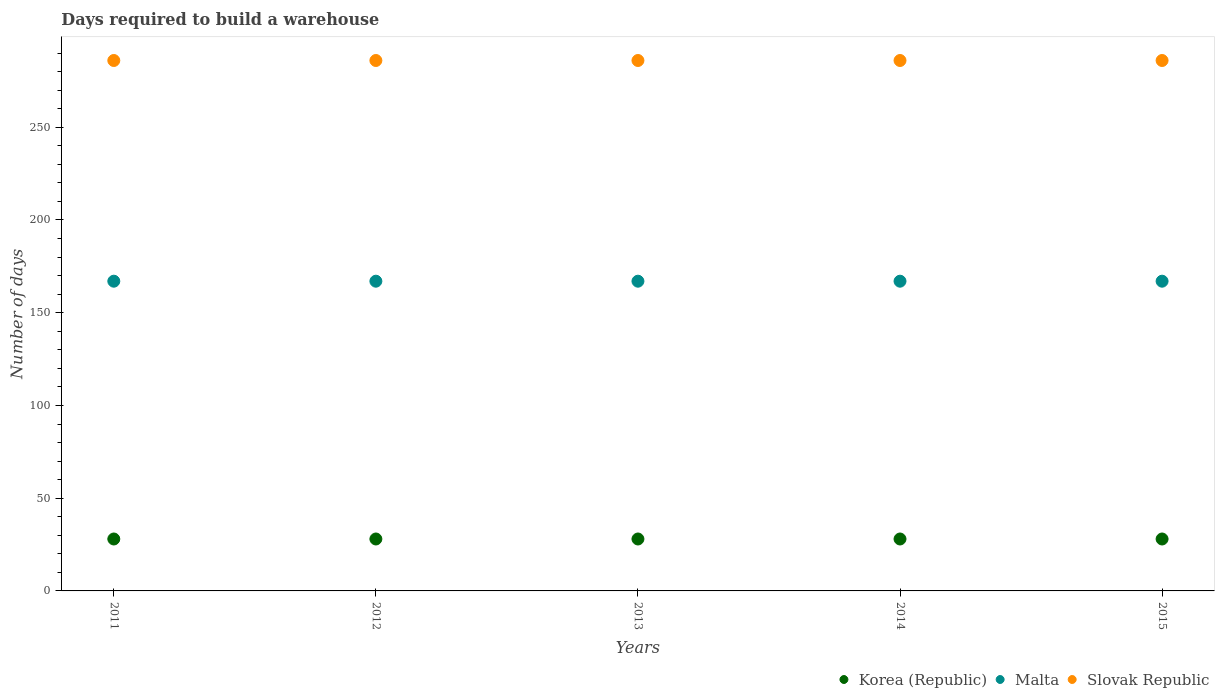Is the number of dotlines equal to the number of legend labels?
Ensure brevity in your answer.  Yes. What is the days required to build a warehouse in in Slovak Republic in 2012?
Your response must be concise. 286. Across all years, what is the maximum days required to build a warehouse in in Korea (Republic)?
Your response must be concise. 28. Across all years, what is the minimum days required to build a warehouse in in Korea (Republic)?
Give a very brief answer. 28. In which year was the days required to build a warehouse in in Korea (Republic) maximum?
Provide a succinct answer. 2011. In which year was the days required to build a warehouse in in Slovak Republic minimum?
Your answer should be very brief. 2011. What is the total days required to build a warehouse in in Malta in the graph?
Make the answer very short. 835. What is the difference between the days required to build a warehouse in in Korea (Republic) in 2011 and the days required to build a warehouse in in Slovak Republic in 2015?
Your answer should be compact. -258. What is the average days required to build a warehouse in in Malta per year?
Keep it short and to the point. 167. In the year 2012, what is the difference between the days required to build a warehouse in in Malta and days required to build a warehouse in in Korea (Republic)?
Make the answer very short. 139. What is the difference between the highest and the lowest days required to build a warehouse in in Slovak Republic?
Your answer should be compact. 0. Is it the case that in every year, the sum of the days required to build a warehouse in in Korea (Republic) and days required to build a warehouse in in Malta  is greater than the days required to build a warehouse in in Slovak Republic?
Offer a very short reply. No. Is the days required to build a warehouse in in Korea (Republic) strictly less than the days required to build a warehouse in in Malta over the years?
Ensure brevity in your answer.  Yes. How many years are there in the graph?
Provide a short and direct response. 5. What is the difference between two consecutive major ticks on the Y-axis?
Provide a succinct answer. 50. Does the graph contain any zero values?
Your response must be concise. No. Where does the legend appear in the graph?
Ensure brevity in your answer.  Bottom right. What is the title of the graph?
Give a very brief answer. Days required to build a warehouse. Does "Moldova" appear as one of the legend labels in the graph?
Your answer should be compact. No. What is the label or title of the Y-axis?
Provide a short and direct response. Number of days. What is the Number of days of Korea (Republic) in 2011?
Provide a short and direct response. 28. What is the Number of days in Malta in 2011?
Your answer should be compact. 167. What is the Number of days of Slovak Republic in 2011?
Give a very brief answer. 286. What is the Number of days of Malta in 2012?
Offer a terse response. 167. What is the Number of days of Slovak Republic in 2012?
Provide a succinct answer. 286. What is the Number of days in Malta in 2013?
Offer a terse response. 167. What is the Number of days of Slovak Republic in 2013?
Your response must be concise. 286. What is the Number of days in Korea (Republic) in 2014?
Your response must be concise. 28. What is the Number of days of Malta in 2014?
Provide a short and direct response. 167. What is the Number of days of Slovak Republic in 2014?
Provide a succinct answer. 286. What is the Number of days of Malta in 2015?
Your answer should be compact. 167. What is the Number of days in Slovak Republic in 2015?
Make the answer very short. 286. Across all years, what is the maximum Number of days in Korea (Republic)?
Offer a terse response. 28. Across all years, what is the maximum Number of days of Malta?
Keep it short and to the point. 167. Across all years, what is the maximum Number of days of Slovak Republic?
Provide a succinct answer. 286. Across all years, what is the minimum Number of days in Malta?
Make the answer very short. 167. Across all years, what is the minimum Number of days in Slovak Republic?
Your answer should be very brief. 286. What is the total Number of days in Korea (Republic) in the graph?
Your answer should be very brief. 140. What is the total Number of days of Malta in the graph?
Ensure brevity in your answer.  835. What is the total Number of days in Slovak Republic in the graph?
Give a very brief answer. 1430. What is the difference between the Number of days of Korea (Republic) in 2011 and that in 2012?
Your answer should be compact. 0. What is the difference between the Number of days of Malta in 2011 and that in 2012?
Ensure brevity in your answer.  0. What is the difference between the Number of days in Slovak Republic in 2011 and that in 2012?
Your answer should be compact. 0. What is the difference between the Number of days in Korea (Republic) in 2011 and that in 2013?
Your response must be concise. 0. What is the difference between the Number of days of Slovak Republic in 2011 and that in 2013?
Make the answer very short. 0. What is the difference between the Number of days of Korea (Republic) in 2011 and that in 2014?
Your response must be concise. 0. What is the difference between the Number of days of Malta in 2011 and that in 2014?
Your response must be concise. 0. What is the difference between the Number of days in Korea (Republic) in 2011 and that in 2015?
Provide a short and direct response. 0. What is the difference between the Number of days of Slovak Republic in 2011 and that in 2015?
Ensure brevity in your answer.  0. What is the difference between the Number of days in Korea (Republic) in 2012 and that in 2013?
Offer a very short reply. 0. What is the difference between the Number of days in Malta in 2012 and that in 2013?
Provide a short and direct response. 0. What is the difference between the Number of days in Malta in 2012 and that in 2014?
Your response must be concise. 0. What is the difference between the Number of days in Korea (Republic) in 2012 and that in 2015?
Your response must be concise. 0. What is the difference between the Number of days of Malta in 2012 and that in 2015?
Provide a succinct answer. 0. What is the difference between the Number of days in Slovak Republic in 2012 and that in 2015?
Give a very brief answer. 0. What is the difference between the Number of days of Korea (Republic) in 2013 and that in 2014?
Provide a succinct answer. 0. What is the difference between the Number of days of Slovak Republic in 2013 and that in 2014?
Offer a very short reply. 0. What is the difference between the Number of days of Korea (Republic) in 2013 and that in 2015?
Give a very brief answer. 0. What is the difference between the Number of days of Slovak Republic in 2014 and that in 2015?
Your response must be concise. 0. What is the difference between the Number of days of Korea (Republic) in 2011 and the Number of days of Malta in 2012?
Keep it short and to the point. -139. What is the difference between the Number of days of Korea (Republic) in 2011 and the Number of days of Slovak Republic in 2012?
Your answer should be compact. -258. What is the difference between the Number of days in Malta in 2011 and the Number of days in Slovak Republic in 2012?
Give a very brief answer. -119. What is the difference between the Number of days of Korea (Republic) in 2011 and the Number of days of Malta in 2013?
Provide a succinct answer. -139. What is the difference between the Number of days in Korea (Republic) in 2011 and the Number of days in Slovak Republic in 2013?
Your answer should be compact. -258. What is the difference between the Number of days of Malta in 2011 and the Number of days of Slovak Republic in 2013?
Offer a terse response. -119. What is the difference between the Number of days of Korea (Republic) in 2011 and the Number of days of Malta in 2014?
Keep it short and to the point. -139. What is the difference between the Number of days in Korea (Republic) in 2011 and the Number of days in Slovak Republic in 2014?
Keep it short and to the point. -258. What is the difference between the Number of days of Malta in 2011 and the Number of days of Slovak Republic in 2014?
Provide a short and direct response. -119. What is the difference between the Number of days of Korea (Republic) in 2011 and the Number of days of Malta in 2015?
Provide a short and direct response. -139. What is the difference between the Number of days in Korea (Republic) in 2011 and the Number of days in Slovak Republic in 2015?
Offer a terse response. -258. What is the difference between the Number of days in Malta in 2011 and the Number of days in Slovak Republic in 2015?
Make the answer very short. -119. What is the difference between the Number of days of Korea (Republic) in 2012 and the Number of days of Malta in 2013?
Ensure brevity in your answer.  -139. What is the difference between the Number of days of Korea (Republic) in 2012 and the Number of days of Slovak Republic in 2013?
Your answer should be compact. -258. What is the difference between the Number of days in Malta in 2012 and the Number of days in Slovak Republic in 2013?
Your response must be concise. -119. What is the difference between the Number of days of Korea (Republic) in 2012 and the Number of days of Malta in 2014?
Your response must be concise. -139. What is the difference between the Number of days of Korea (Republic) in 2012 and the Number of days of Slovak Republic in 2014?
Provide a succinct answer. -258. What is the difference between the Number of days in Malta in 2012 and the Number of days in Slovak Republic in 2014?
Provide a short and direct response. -119. What is the difference between the Number of days in Korea (Republic) in 2012 and the Number of days in Malta in 2015?
Offer a very short reply. -139. What is the difference between the Number of days of Korea (Republic) in 2012 and the Number of days of Slovak Republic in 2015?
Your response must be concise. -258. What is the difference between the Number of days in Malta in 2012 and the Number of days in Slovak Republic in 2015?
Keep it short and to the point. -119. What is the difference between the Number of days of Korea (Republic) in 2013 and the Number of days of Malta in 2014?
Your response must be concise. -139. What is the difference between the Number of days of Korea (Republic) in 2013 and the Number of days of Slovak Republic in 2014?
Give a very brief answer. -258. What is the difference between the Number of days of Malta in 2013 and the Number of days of Slovak Republic in 2014?
Give a very brief answer. -119. What is the difference between the Number of days of Korea (Republic) in 2013 and the Number of days of Malta in 2015?
Make the answer very short. -139. What is the difference between the Number of days of Korea (Republic) in 2013 and the Number of days of Slovak Republic in 2015?
Offer a terse response. -258. What is the difference between the Number of days of Malta in 2013 and the Number of days of Slovak Republic in 2015?
Provide a short and direct response. -119. What is the difference between the Number of days of Korea (Republic) in 2014 and the Number of days of Malta in 2015?
Make the answer very short. -139. What is the difference between the Number of days of Korea (Republic) in 2014 and the Number of days of Slovak Republic in 2015?
Offer a very short reply. -258. What is the difference between the Number of days of Malta in 2014 and the Number of days of Slovak Republic in 2015?
Offer a terse response. -119. What is the average Number of days in Korea (Republic) per year?
Ensure brevity in your answer.  28. What is the average Number of days in Malta per year?
Ensure brevity in your answer.  167. What is the average Number of days of Slovak Republic per year?
Your answer should be very brief. 286. In the year 2011, what is the difference between the Number of days in Korea (Republic) and Number of days in Malta?
Ensure brevity in your answer.  -139. In the year 2011, what is the difference between the Number of days in Korea (Republic) and Number of days in Slovak Republic?
Your response must be concise. -258. In the year 2011, what is the difference between the Number of days in Malta and Number of days in Slovak Republic?
Provide a succinct answer. -119. In the year 2012, what is the difference between the Number of days in Korea (Republic) and Number of days in Malta?
Ensure brevity in your answer.  -139. In the year 2012, what is the difference between the Number of days in Korea (Republic) and Number of days in Slovak Republic?
Your answer should be compact. -258. In the year 2012, what is the difference between the Number of days in Malta and Number of days in Slovak Republic?
Ensure brevity in your answer.  -119. In the year 2013, what is the difference between the Number of days in Korea (Republic) and Number of days in Malta?
Your answer should be very brief. -139. In the year 2013, what is the difference between the Number of days in Korea (Republic) and Number of days in Slovak Republic?
Keep it short and to the point. -258. In the year 2013, what is the difference between the Number of days in Malta and Number of days in Slovak Republic?
Your answer should be compact. -119. In the year 2014, what is the difference between the Number of days in Korea (Republic) and Number of days in Malta?
Your answer should be compact. -139. In the year 2014, what is the difference between the Number of days in Korea (Republic) and Number of days in Slovak Republic?
Offer a very short reply. -258. In the year 2014, what is the difference between the Number of days in Malta and Number of days in Slovak Republic?
Your answer should be compact. -119. In the year 2015, what is the difference between the Number of days in Korea (Republic) and Number of days in Malta?
Offer a terse response. -139. In the year 2015, what is the difference between the Number of days of Korea (Republic) and Number of days of Slovak Republic?
Make the answer very short. -258. In the year 2015, what is the difference between the Number of days in Malta and Number of days in Slovak Republic?
Your answer should be very brief. -119. What is the ratio of the Number of days in Korea (Republic) in 2011 to that in 2012?
Make the answer very short. 1. What is the ratio of the Number of days of Malta in 2011 to that in 2012?
Ensure brevity in your answer.  1. What is the ratio of the Number of days of Slovak Republic in 2011 to that in 2012?
Offer a terse response. 1. What is the ratio of the Number of days in Korea (Republic) in 2011 to that in 2013?
Provide a succinct answer. 1. What is the ratio of the Number of days in Korea (Republic) in 2011 to that in 2014?
Ensure brevity in your answer.  1. What is the ratio of the Number of days in Malta in 2011 to that in 2014?
Ensure brevity in your answer.  1. What is the ratio of the Number of days in Malta in 2011 to that in 2015?
Offer a terse response. 1. What is the ratio of the Number of days in Slovak Republic in 2012 to that in 2013?
Offer a very short reply. 1. What is the ratio of the Number of days of Malta in 2012 to that in 2014?
Offer a very short reply. 1. What is the ratio of the Number of days of Korea (Republic) in 2012 to that in 2015?
Ensure brevity in your answer.  1. What is the ratio of the Number of days of Malta in 2012 to that in 2015?
Your answer should be compact. 1. What is the ratio of the Number of days of Korea (Republic) in 2013 to that in 2014?
Make the answer very short. 1. What is the ratio of the Number of days in Malta in 2013 to that in 2014?
Keep it short and to the point. 1. What is the ratio of the Number of days of Korea (Republic) in 2013 to that in 2015?
Offer a terse response. 1. What is the ratio of the Number of days of Malta in 2013 to that in 2015?
Your answer should be very brief. 1. What is the ratio of the Number of days in Slovak Republic in 2013 to that in 2015?
Your response must be concise. 1. What is the ratio of the Number of days of Malta in 2014 to that in 2015?
Offer a terse response. 1. What is the ratio of the Number of days in Slovak Republic in 2014 to that in 2015?
Provide a succinct answer. 1. What is the difference between the highest and the second highest Number of days in Malta?
Keep it short and to the point. 0. What is the difference between the highest and the lowest Number of days in Malta?
Offer a very short reply. 0. What is the difference between the highest and the lowest Number of days in Slovak Republic?
Offer a terse response. 0. 